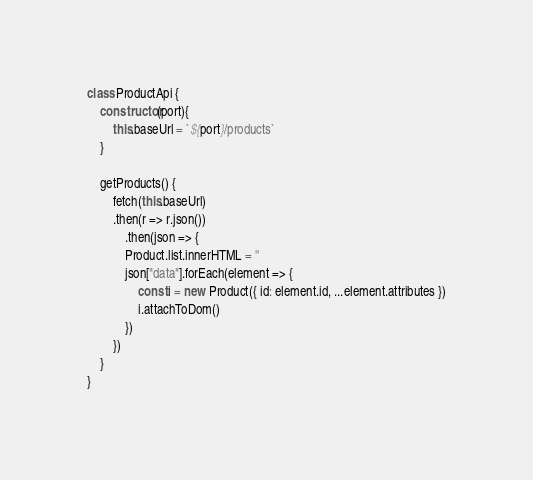<code> <loc_0><loc_0><loc_500><loc_500><_JavaScript_>class ProductApi {
    constructor(port){  
        this.baseUrl = `${port}/products`
    } 

    getProducts() {
        fetch(this.baseUrl)
        .then(r => r.json())
            .then(json => {
            Product.list.innerHTML = ''
            json["data"].forEach(element => {
                const i = new Product({ id: element.id, ...element.attributes })
                i.attachToDom()
            })
        })
    }
}</code> 